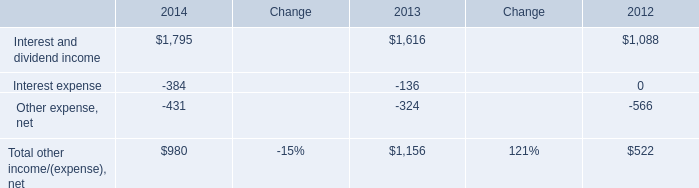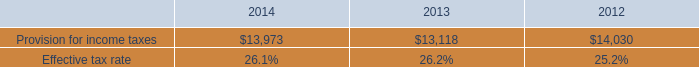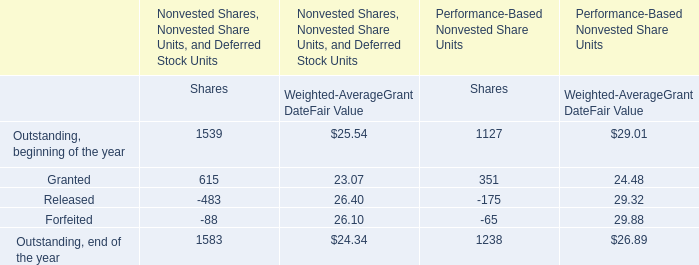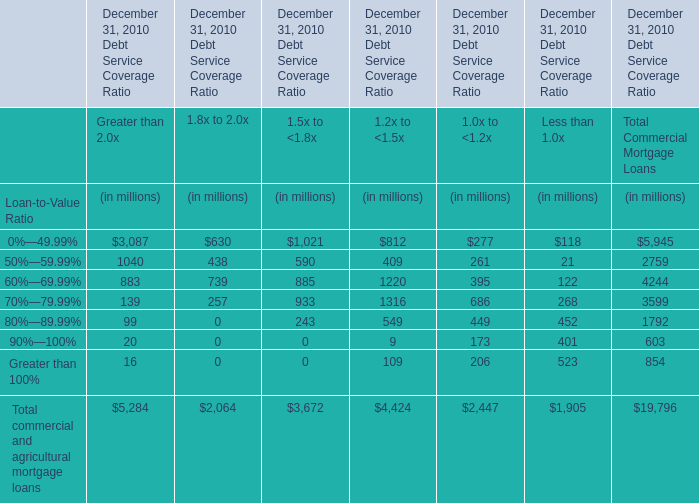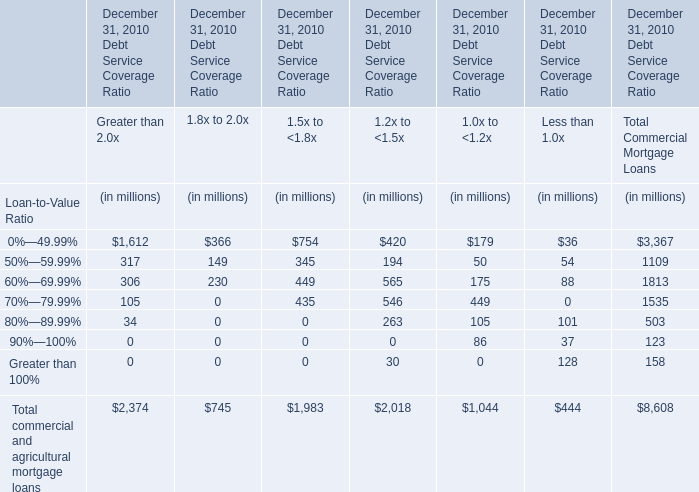What is the total amount of Interest and dividend income of 2013, and Provision for income taxes of 2013 ? 
Computations: (1616.0 + 13118.0)
Answer: 14734.0. 